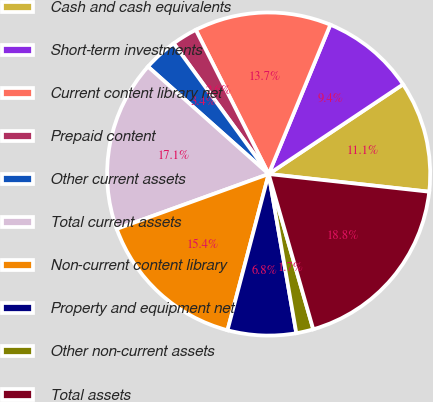Convert chart. <chart><loc_0><loc_0><loc_500><loc_500><pie_chart><fcel>Cash and cash equivalents<fcel>Short-term investments<fcel>Current content library net<fcel>Prepaid content<fcel>Other current assets<fcel>Total current assets<fcel>Non-current content library<fcel>Property and equipment net<fcel>Other non-current assets<fcel>Total assets<nl><fcel>11.11%<fcel>9.4%<fcel>13.68%<fcel>2.56%<fcel>3.42%<fcel>17.09%<fcel>15.38%<fcel>6.84%<fcel>1.71%<fcel>18.8%<nl></chart> 